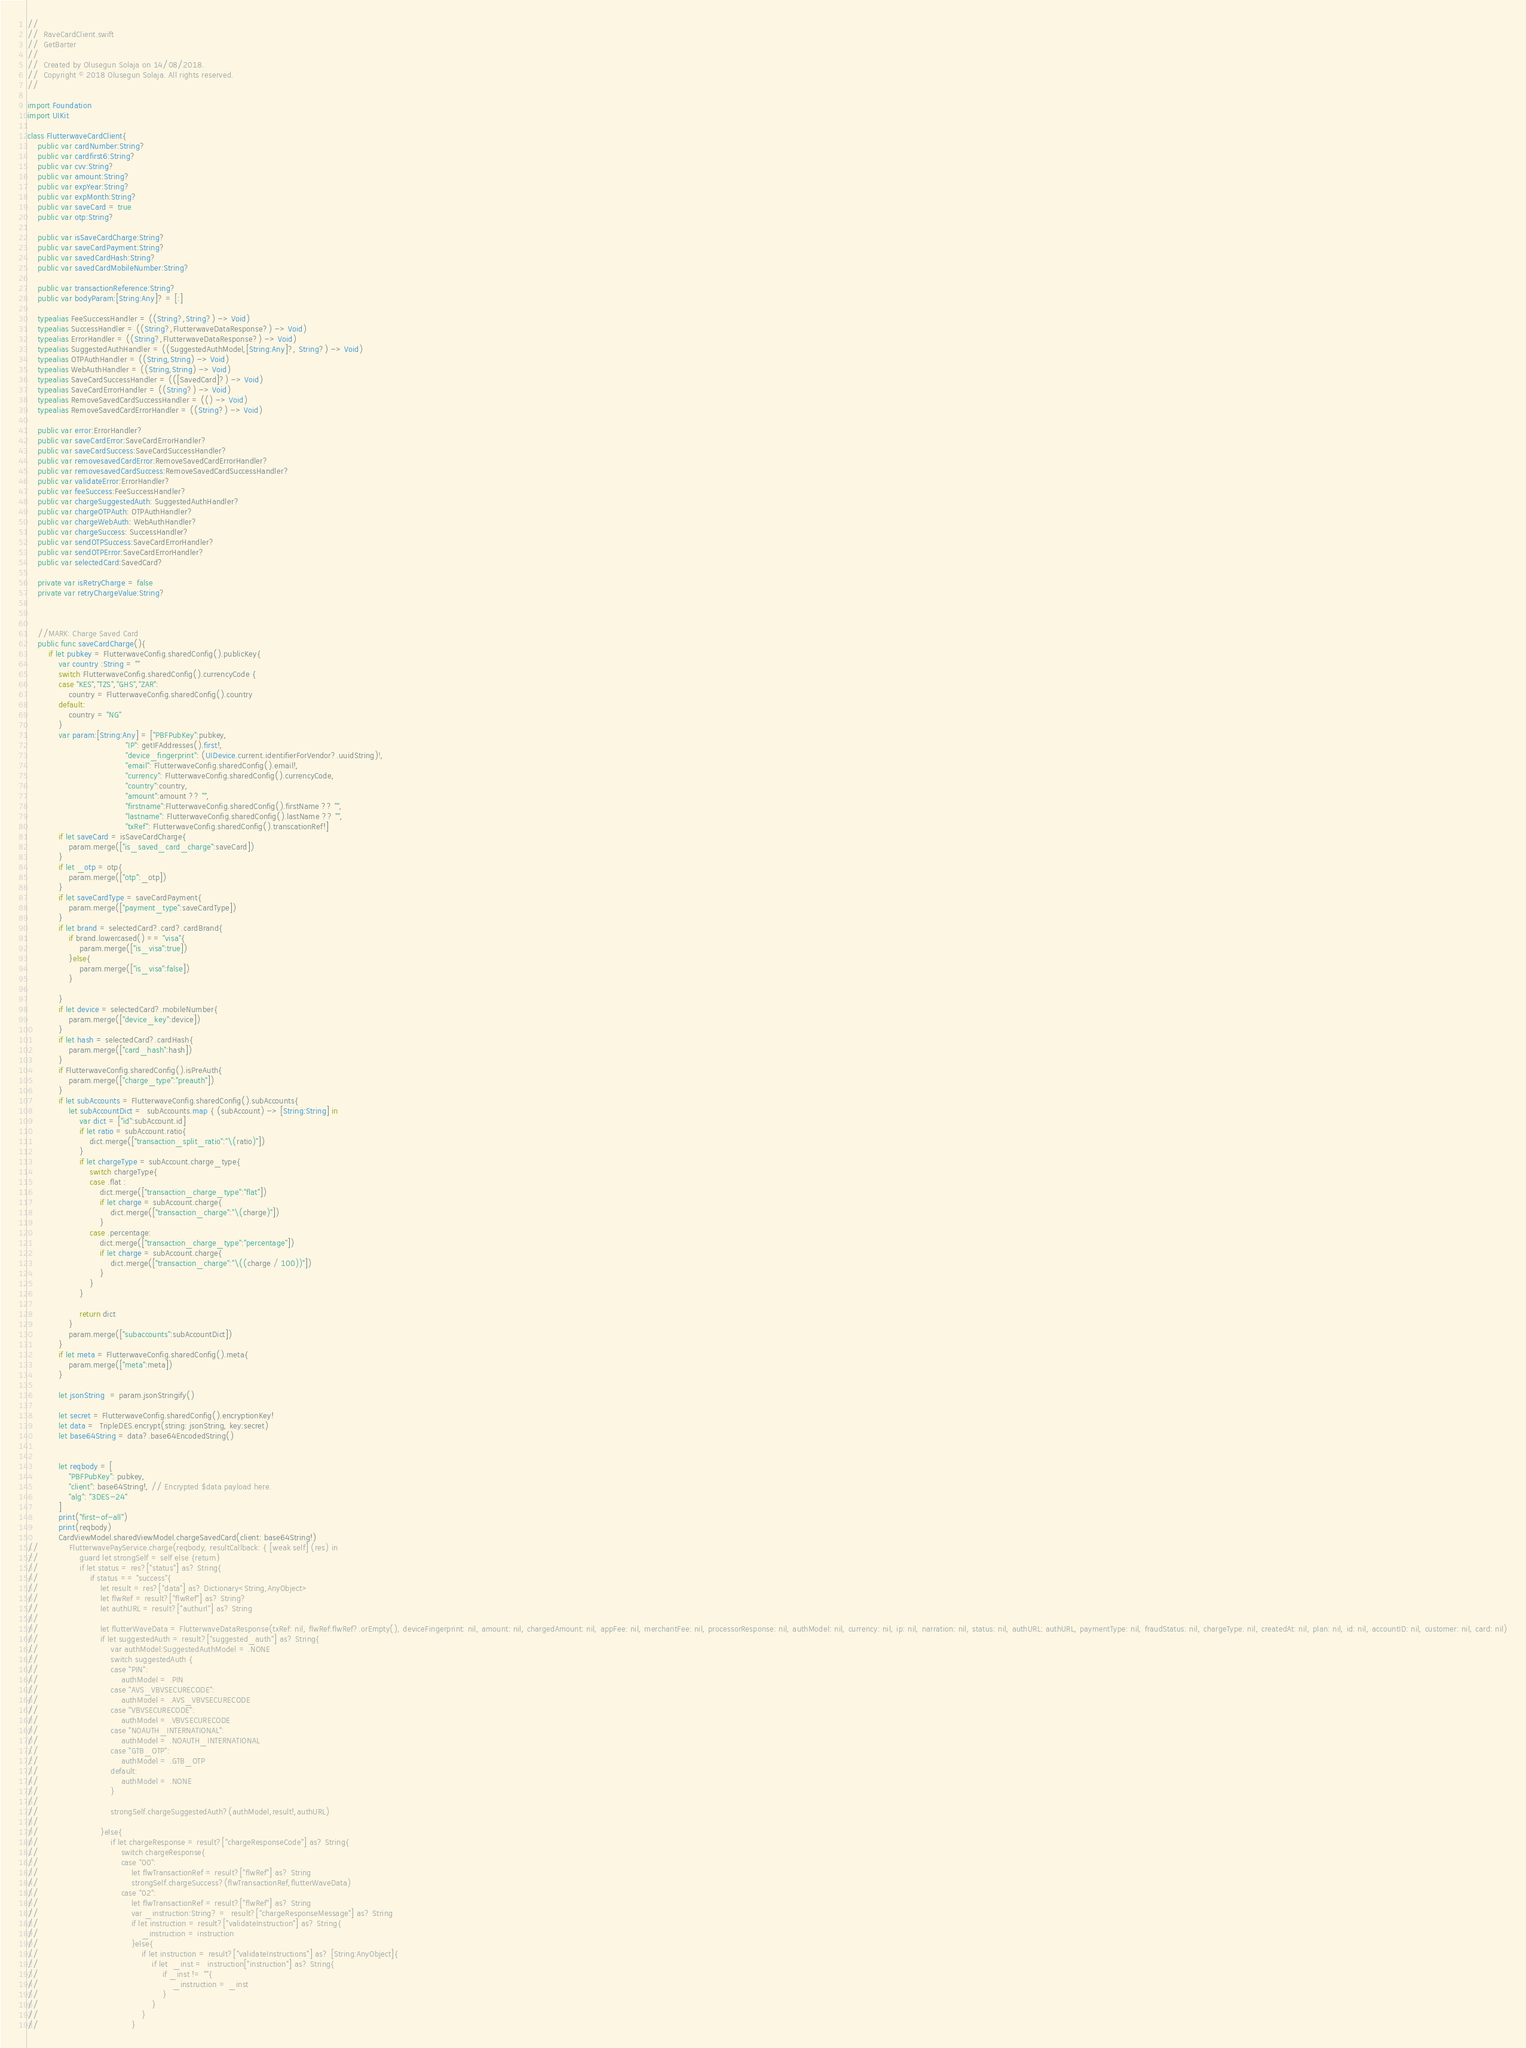<code> <loc_0><loc_0><loc_500><loc_500><_Swift_>//
//  RaveCardClient.swift
//  GetBarter
//
//  Created by Olusegun Solaja on 14/08/2018.
//  Copyright © 2018 Olusegun Solaja. All rights reserved.
//

import Foundation
import UIKit

class FlutterwaveCardClient{
    public var cardNumber:String?
    public var cardfirst6:String?
    public var cvv:String?
    public var amount:String?
    public var expYear:String?
    public var expMonth:String?
    public var saveCard = true
    public var otp:String?
    
    public var isSaveCardCharge:String?
    public var saveCardPayment:String?
    public var savedCardHash:String?
    public var savedCardMobileNumber:String?
    
    public var transactionReference:String?
    public var bodyParam:[String:Any]? = [:]
    
    typealias FeeSuccessHandler = ((String?,String?) -> Void)
    typealias SuccessHandler = ((String?,FlutterwaveDataResponse?) -> Void)
    typealias ErrorHandler = ((String?,FlutterwaveDataResponse?) -> Void)
    typealias SuggestedAuthHandler = ((SuggestedAuthModel,[String:Any]?, String?) -> Void)
    typealias OTPAuthHandler = ((String,String) -> Void)
    typealias WebAuthHandler = ((String,String) -> Void)
    typealias SaveCardSuccessHandler = (([SavedCard]?) -> Void)
    typealias SaveCardErrorHandler = ((String?) -> Void)
    typealias RemoveSavedCardSuccessHandler = (() -> Void)
    typealias RemoveSavedCardErrorHandler = ((String?) -> Void)
    
    public var error:ErrorHandler?
    public var saveCardError:SaveCardErrorHandler?
    public var saveCardSuccess:SaveCardSuccessHandler?
    public var removesavedCardError:RemoveSavedCardErrorHandler?
    public var removesavedCardSuccess:RemoveSavedCardSuccessHandler?
    public var validateError:ErrorHandler?
    public var feeSuccess:FeeSuccessHandler?
    public var chargeSuggestedAuth: SuggestedAuthHandler?
    public var chargeOTPAuth: OTPAuthHandler?
    public var chargeWebAuth: WebAuthHandler?
    public var chargeSuccess: SuccessHandler?
    public var sendOTPSuccess:SaveCardErrorHandler?
    public var sendOTPError:SaveCardErrorHandler?
    public var selectedCard:SavedCard?
    
    private var isRetryCharge = false
    private var retryChargeValue:String?
    
    
    
    //MARK: Charge Saved Card
    public func saveCardCharge(){
        if let pubkey = FlutterwaveConfig.sharedConfig().publicKey{
            var country :String = ""
            switch FlutterwaveConfig.sharedConfig().currencyCode {
            case "KES","TZS","GHS","ZAR":
                country = FlutterwaveConfig.sharedConfig().country
            default:
                country = "NG"
            }
            var param:[String:Any] = ["PBFPubKey":pubkey,
                                      "IP": getIFAddresses().first!,
                                      "device_fingerprint": (UIDevice.current.identifierForVendor?.uuidString)!,
                                      "email": FlutterwaveConfig.sharedConfig().email!,
                                      "currency": FlutterwaveConfig.sharedConfig().currencyCode,
                                      "country":country,
                                      "amount":amount ?? "",
                                      "firstname":FlutterwaveConfig.sharedConfig().firstName ?? "",
                                      "lastname": FlutterwaveConfig.sharedConfig().lastName ?? "",
                                      "txRef": FlutterwaveConfig.sharedConfig().transcationRef!]
            if let saveCard = isSaveCardCharge{
                param.merge(["is_saved_card_charge":saveCard])
            }
            if let _otp = otp{
                param.merge(["otp":_otp])
            }
            if let saveCardType = saveCardPayment{
                param.merge(["payment_type":saveCardType])
            }
            if let brand = selectedCard?.card?.cardBrand{
                if brand.lowercased() == "visa"{
                    param.merge(["is_visa":true])
                }else{
                    param.merge(["is_visa":false])
                }
                
            }
            if let device = selectedCard?.mobileNumber{
                param.merge(["device_key":device])
            }
            if let hash = selectedCard?.cardHash{
                param.merge(["card_hash":hash])
            }
            if FlutterwaveConfig.sharedConfig().isPreAuth{
                param.merge(["charge_type":"preauth"])
            }
            if let subAccounts = FlutterwaveConfig.sharedConfig().subAccounts{
                let subAccountDict =  subAccounts.map { (subAccount) -> [String:String] in
                    var dict = ["id":subAccount.id]
                    if let ratio = subAccount.ratio{
                        dict.merge(["transaction_split_ratio":"\(ratio)"])
                    }
                    if let chargeType = subAccount.charge_type{
                        switch chargeType{
                        case .flat :
                            dict.merge(["transaction_charge_type":"flat"])
                            if let charge = subAccount.charge{
                                dict.merge(["transaction_charge":"\(charge)"])
                            }
                        case .percentage:
                            dict.merge(["transaction_charge_type":"percentage"])
                            if let charge = subAccount.charge{
                                dict.merge(["transaction_charge":"\((charge / 100))"])
                            }
                        }
                    }
                    
                    return dict
                }
                param.merge(["subaccounts":subAccountDict])
            }
            if let meta = FlutterwaveConfig.sharedConfig().meta{
                param.merge(["meta":meta])
            }
            
            let jsonString  = param.jsonStringify()
            
            let secret = FlutterwaveConfig.sharedConfig().encryptionKey!
            let data =  TripleDES.encrypt(string: jsonString, key:secret)
            let base64String = data?.base64EncodedString()
            
            
            let reqbody = [
                "PBFPubKey": pubkey,
                "client": base64String!, // Encrypted $data payload here.
                "alg": "3DES-24"
            ]
            print("first-of-all")
            print(reqbody)
            CardViewModel.sharedViewModel.chargeSavedCard(client: base64String!)
//            FlutterwavePayService.charge(reqbody, resultCallback: { [weak self] (res) in
//                guard let strongSelf = self else {return}
//                if let status = res?["status"] as? String{
//                    if status == "success"{
//                        let result = res?["data"] as? Dictionary<String,AnyObject>
//                        let flwRef = result?["flwRef"] as? String?
//                        let authURL = result?["authurl"] as? String
//
//                        let flutterWaveData = FlutterwaveDataResponse(txRef: nil, flwRef:flwRef?.orEmpty(), deviceFingerprint: nil, amount: nil, chargedAmount: nil, appFee: nil, merchantFee: nil, processorResponse: nil, authModel: nil, currency: nil, ip: nil, narration: nil, status: nil, authURL: authURL, paymentType: nil, fraudStatus: nil, chargeType: nil, createdAt: nil, plan: nil, id: nil, accountID: nil, customer: nil, card: nil)
//                        if let suggestedAuth = result?["suggested_auth"] as? String{
//                            var authModel:SuggestedAuthModel = .NONE
//                            switch suggestedAuth {
//                            case "PIN":
//                                authModel = .PIN
//                            case "AVS_VBVSECURECODE":
//                                authModel = .AVS_VBVSECURECODE
//                            case "VBVSECURECODE":
//                                authModel = .VBVSECURECODE
//                            case "NOAUTH_INTERNATIONAL":
//                                authModel = .NOAUTH_INTERNATIONAL
//                            case "GTB_OTP":
//                                authModel = .GTB_OTP
//                            default:
//                                authModel = .NONE
//                            }
//
//                            strongSelf.chargeSuggestedAuth?(authModel,result!,authURL)
//
//                        }else{
//                            if let chargeResponse = result?["chargeResponseCode"] as? String{
//                                switch chargeResponse{
//                                case "00":
//                                    let flwTransactionRef = result?["flwRef"] as? String
//                                    strongSelf.chargeSuccess?(flwTransactionRef,flutterWaveData)
//                                case "02":
//                                    let flwTransactionRef = result?["flwRef"] as? String
//                                    var _instruction:String? =  result?["chargeResponseMessage"] as? String
//                                    if let instruction = result?["validateInstruction"] as? String{
//                                        _instruction = instruction
//                                    }else{
//                                        if let instruction = result?["validateInstructions"] as? [String:AnyObject]{
//                                            if let  _inst =  instruction["instruction"] as? String{
//                                                if _inst != ""{
//                                                    _instruction = _inst
//                                                }
//                                            }
//                                        }
//                                    }</code> 